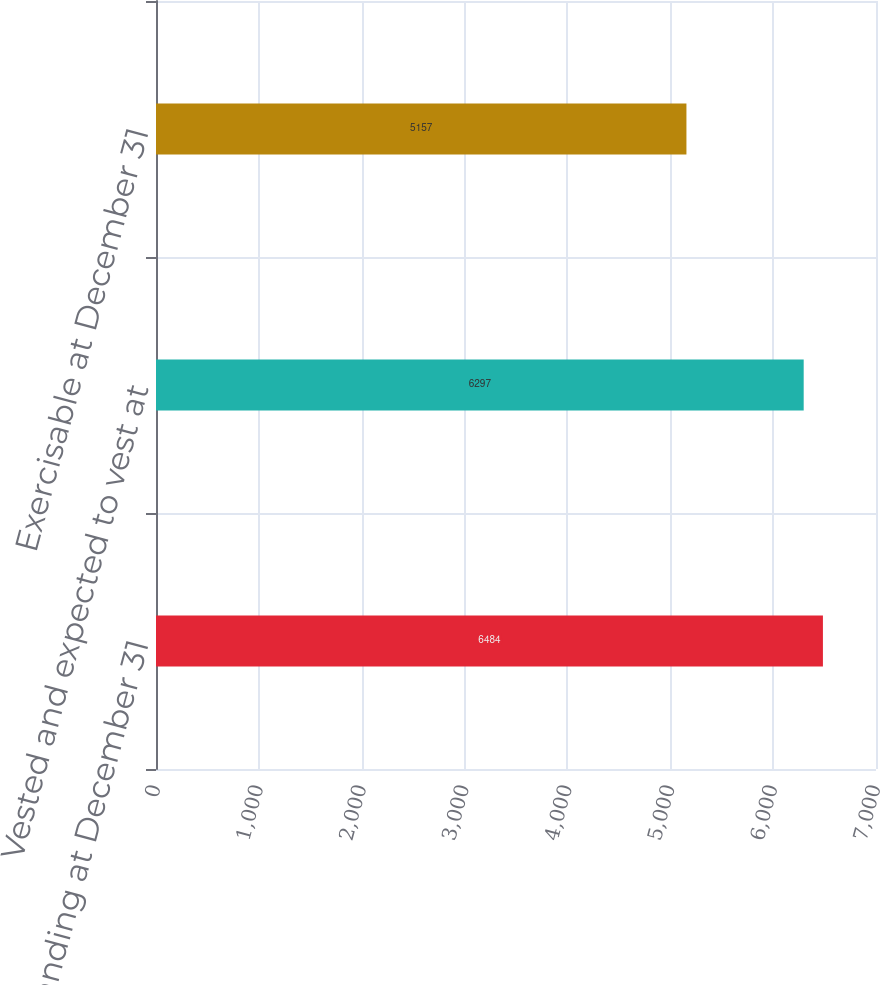Convert chart to OTSL. <chart><loc_0><loc_0><loc_500><loc_500><bar_chart><fcel>Outstanding at December 31<fcel>Vested and expected to vest at<fcel>Exercisable at December 31<nl><fcel>6484<fcel>6297<fcel>5157<nl></chart> 